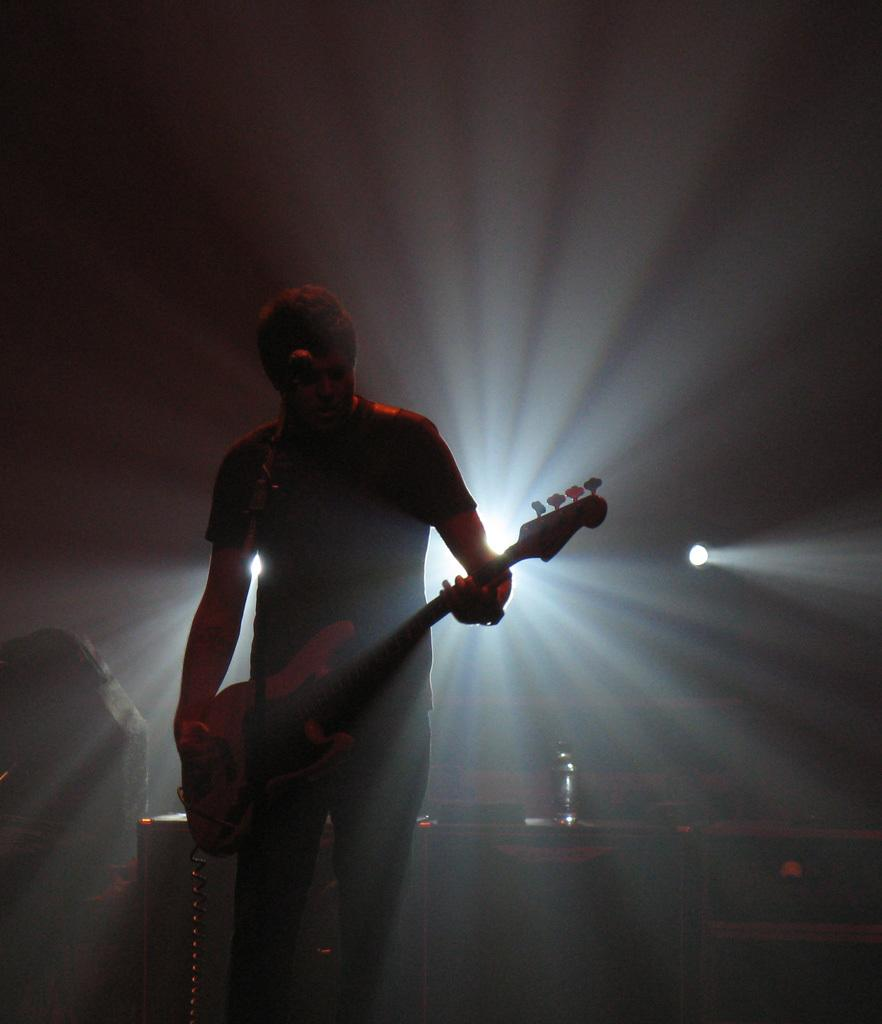What is the main subject of the image? There is a man standing in the center of the image. What is the man holding in the image? The man is holding a guitar. What is the man doing with the microphone in the image? The man is singing on a microphone. What type of coil is wrapped around the man's neck in the image? There is no coil wrapped around the man's neck in the image. How many goldfish can be seen swimming in the background of the image? There are no goldfish present in the image. 